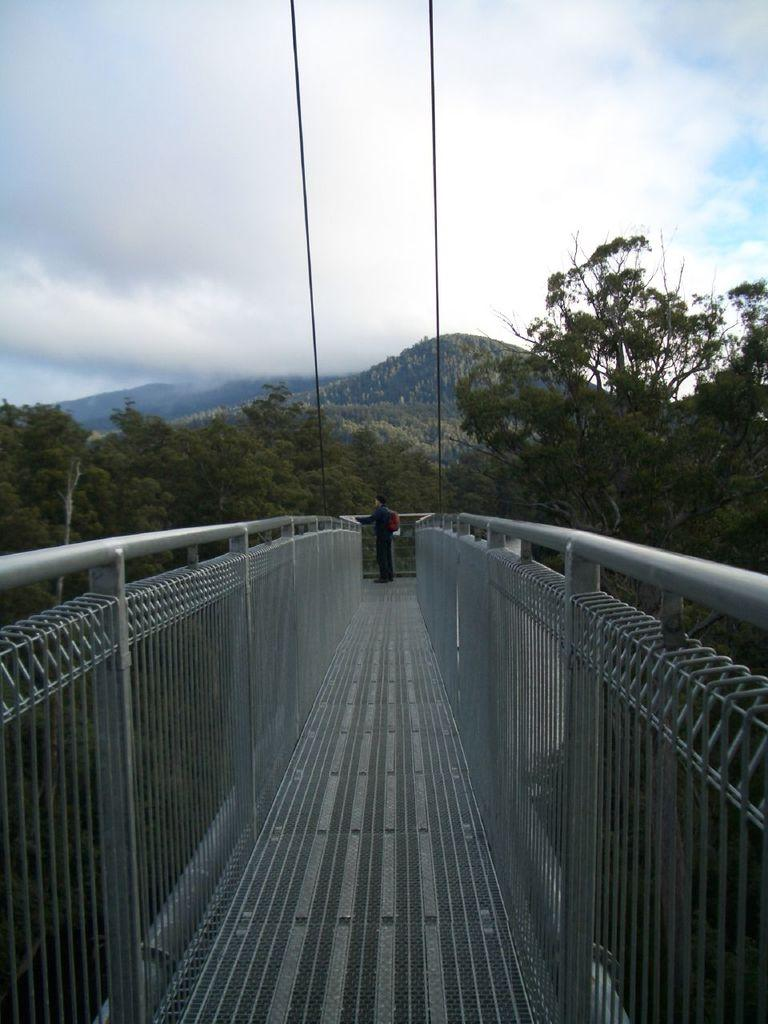What structure can be seen in the image? There is a bridge in the image. Can you describe the person in the image? There is a person standing in the background. What objects are present in the image that might be used for support or attachment? Ropes are present in the image. What type of natural environment is visible in the background? Trees, mountains, and clouds are visible in the background. What type of zephyr can be seen blowing through the image? There is no zephyr present in the image. Can you describe the mitten that the person in the image is wearing? There is no mitten visible in the image, as the person is not wearing any gloves or mittens. 